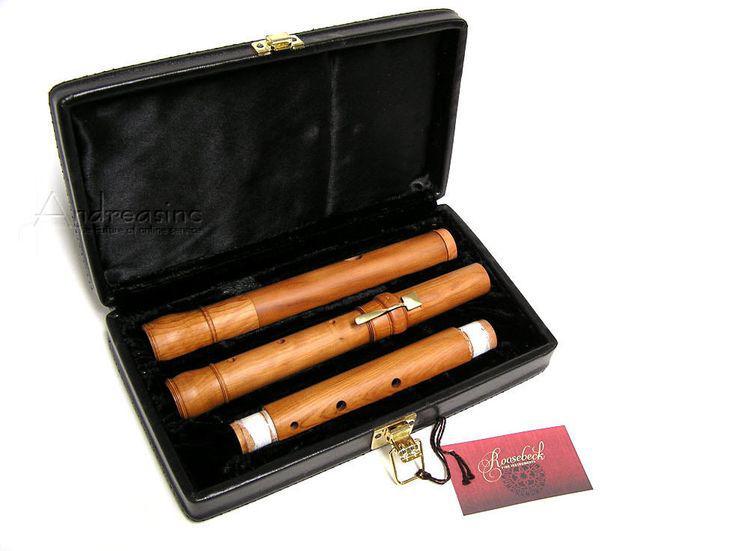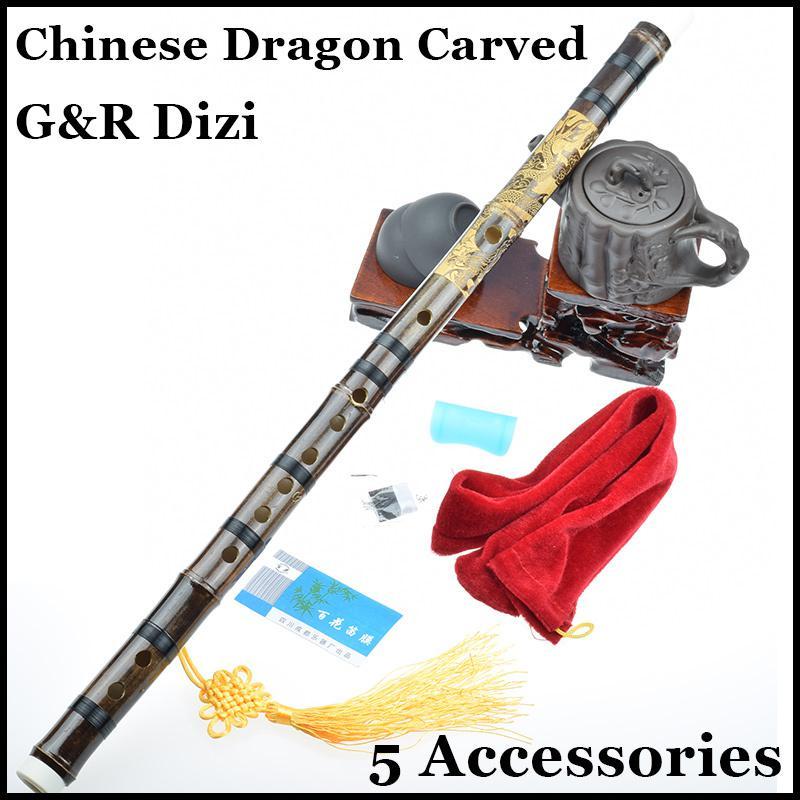The first image is the image on the left, the second image is the image on the right. Considering the images on both sides, is "One image shows a horizontal row of round metal keys with open centers on a tube-shaped metal instrument, and the other image shows one wooden flute with holes but no keys and several stripes around it." valid? Answer yes or no. No. 